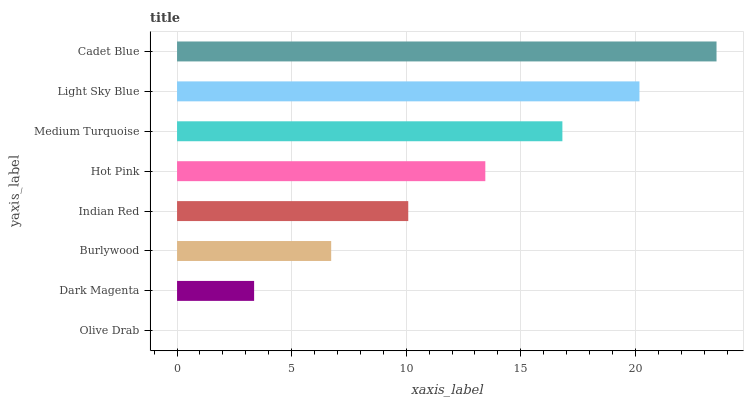Is Olive Drab the minimum?
Answer yes or no. Yes. Is Cadet Blue the maximum?
Answer yes or no. Yes. Is Dark Magenta the minimum?
Answer yes or no. No. Is Dark Magenta the maximum?
Answer yes or no. No. Is Dark Magenta greater than Olive Drab?
Answer yes or no. Yes. Is Olive Drab less than Dark Magenta?
Answer yes or no. Yes. Is Olive Drab greater than Dark Magenta?
Answer yes or no. No. Is Dark Magenta less than Olive Drab?
Answer yes or no. No. Is Hot Pink the high median?
Answer yes or no. Yes. Is Indian Red the low median?
Answer yes or no. Yes. Is Light Sky Blue the high median?
Answer yes or no. No. Is Olive Drab the low median?
Answer yes or no. No. 